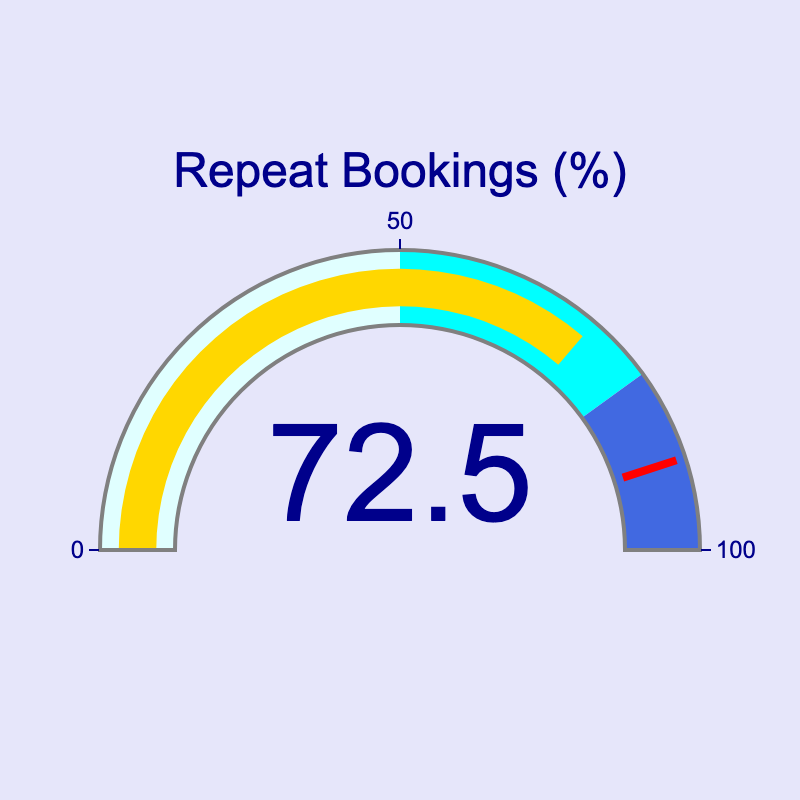What is the percentage of repeat bookings? The gauge chart shows a single number representing the percentage of repeat bookings. It is displayed inside the gauge.
Answer: 72.5% What does the red line on the gauge represent? The red line on the gauge indicates a threshold value. This is typically used to highlight a specific level of interest or concern.
Answer: Threshold value What is the color of the section for values between 50 and 80? The gauge chart has different colors for different ranges. The section for values between 50 and 80 is cyan.
Answer: Cyan Is the proportion of repeat bookings closer to 100% or 50%? The value displayed on the gauge is 72.5% which is closer to 100% than to 50%.
Answer: Closer to 100% In which colored section does the value 72.5% fall? The gauge chart is divided into colored sections: light cyan for 0-50%, cyan for 50-80%, and royal blue for 80-100%. The value 72.5% falls within the cyan section.
Answer: Cyan How does the proportion of repeat bookings compare to the 80% threshold? The value of 72.5% is less than the 80% threshold.
Answer: Less than What is the range of the gauge axis, and which tick marks are displayed? The range of the gauge axis is from 0% to 100%. Tick marks are displayed at consistent intervals.
Answer: 0% to 100%, with intervals If the repeat bookings increase by 10 percentage points, which section would it fall into? Adding 10 percentage points to 72.5% results in 82.5%. This falls into the royal blue section (80-100%).
Answer: Royal blue Comparing the cyan and royal blue sections, what proportion does the royal blue section occupy? The royal blue section occupies 20 percentage points (80-100%), while the cyan section occupies 30 percentage points (50-80%). So, the royal blue section is 2/3 the size of the cyan section.
Answer: 2/3 Is the gauge's needle pointing towards the higher or lower end of the cyan section? With the gauge value at 72.5%, the needle is pointing closer to the higher end of the cyan section, as it is closer to 80% than to 50%.
Answer: Higher end 